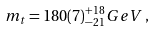<formula> <loc_0><loc_0><loc_500><loc_500>m _ { t } = 1 8 0 ( 7 ) _ { - 2 1 } ^ { + 1 8 } G e V \, ,</formula> 